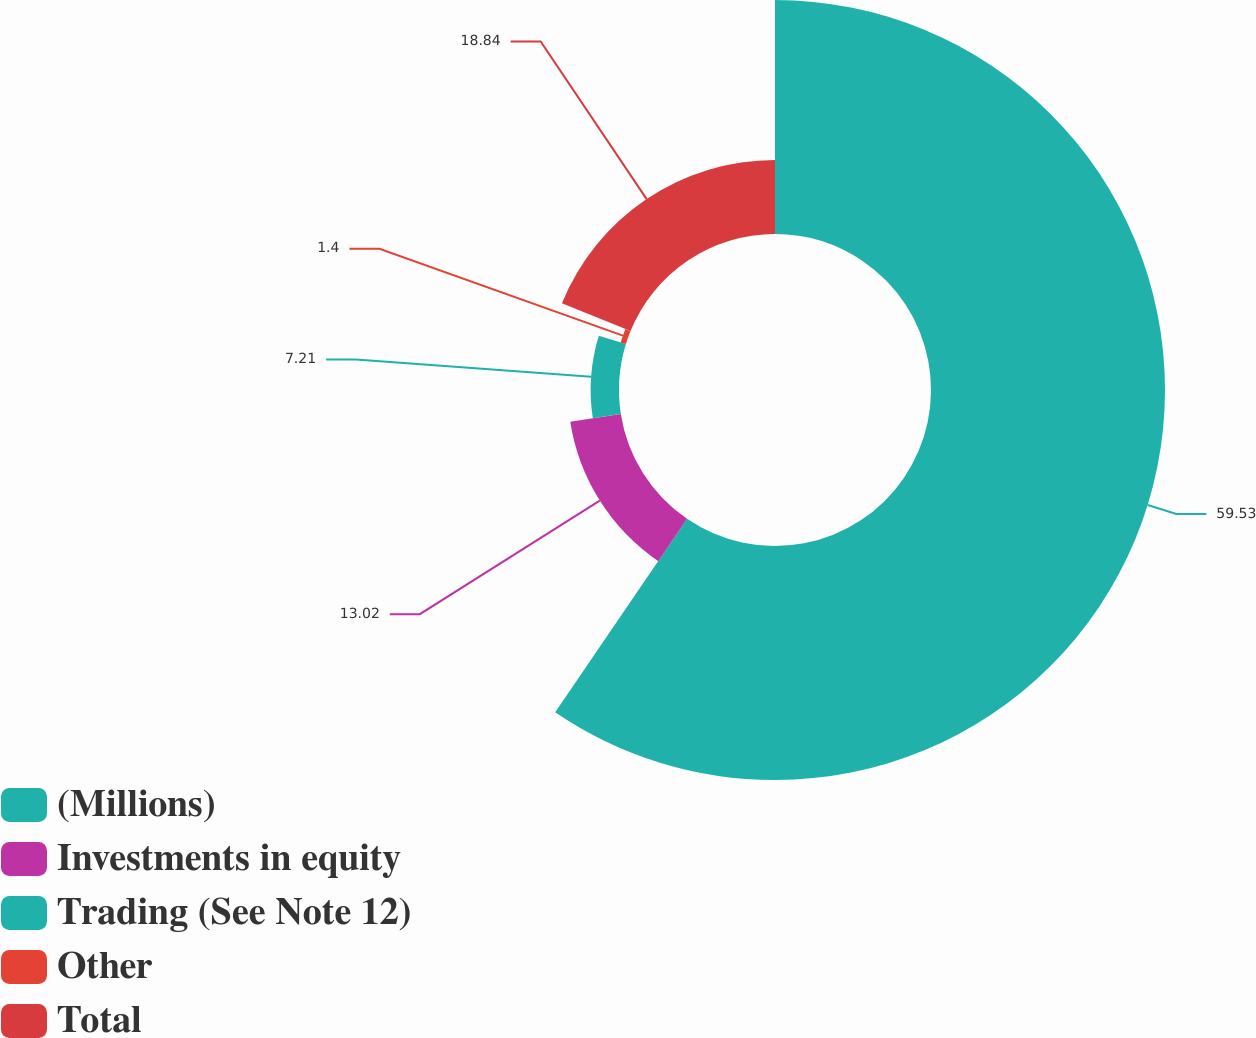Convert chart. <chart><loc_0><loc_0><loc_500><loc_500><pie_chart><fcel>(Millions)<fcel>Investments in equity<fcel>Trading (See Note 12)<fcel>Other<fcel>Total<nl><fcel>59.53%<fcel>13.02%<fcel>7.21%<fcel>1.4%<fcel>18.84%<nl></chart> 